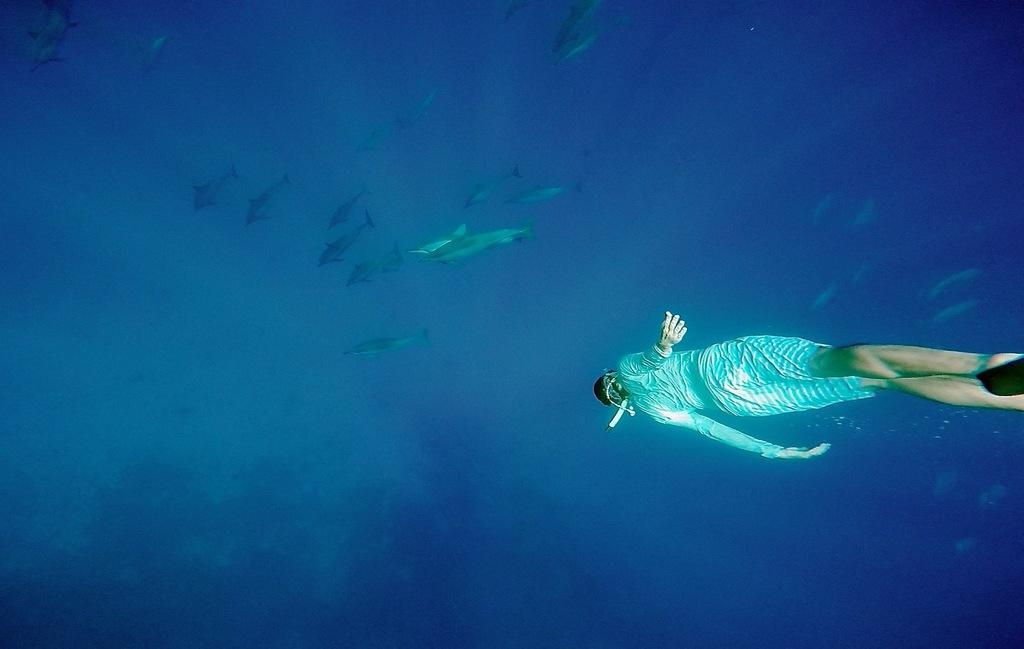What is the person in the image doing? There is a person swimming underwater in the image. What can be seen in front of the person swimming? There are many fishes in front of the person in the image. What type of system is the person using to swim underwater in the image? There is no specific system mentioned or visible in the image; the person is simply swimming underwater. Can you see any coils in the image? There are no coils present in the image. 